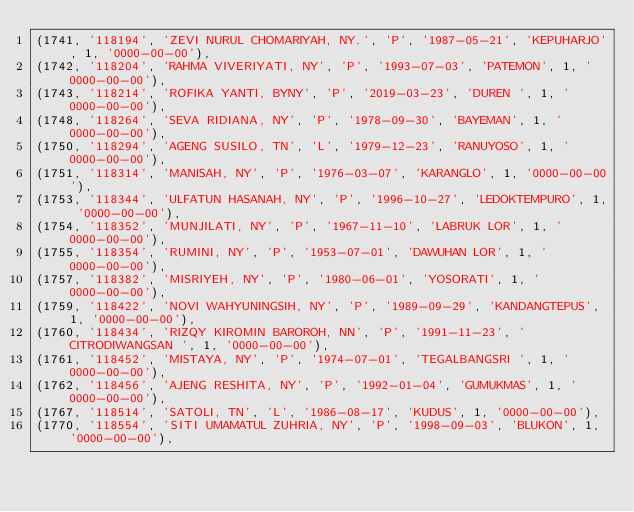Convert code to text. <code><loc_0><loc_0><loc_500><loc_500><_SQL_>(1741, '118194', 'ZEVI NURUL CHOMARIYAH, NY.', 'P', '1987-05-21', 'KEPUHARJO', 1, '0000-00-00'),
(1742, '118204', 'RAHMA VIVERIYATI, NY', 'P', '1993-07-03', 'PATEMON', 1, '0000-00-00'),
(1743, '118214', 'ROFIKA YANTI, BYNY', 'P', '2019-03-23', 'DUREN ', 1, '0000-00-00'),
(1748, '118264', 'SEVA RIDIANA, NY', 'P', '1978-09-30', 'BAYEMAN', 1, '0000-00-00'),
(1750, '118294', 'AGENG SUSILO, TN', 'L', '1979-12-23', 'RANUYOSO', 1, '0000-00-00'),
(1751, '118314', 'MANISAH, NY', 'P', '1976-03-07', 'KARANGLO', 1, '0000-00-00'),
(1753, '118344', 'ULFATUN HASANAH, NY', 'P', '1996-10-27', 'LEDOKTEMPURO', 1, '0000-00-00'),
(1754, '118352', 'MUNJILATI, NY', 'P', '1967-11-10', 'LABRUK LOR', 1, '0000-00-00'),
(1755, '118354', 'RUMINI, NY', 'P', '1953-07-01', 'DAWUHAN LOR', 1, '0000-00-00'),
(1757, '118382', 'MISRIYEH, NY', 'P', '1980-06-01', 'YOSORATI', 1, '0000-00-00'),
(1759, '118422', 'NOVI WAHYUNINGSIH, NY', 'P', '1989-09-29', 'KANDANGTEPUS', 1, '0000-00-00'),
(1760, '118434', 'RIZQY KIROMIN BAROROH, NN', 'P', '1991-11-23', 'CITRODIWANGSAN ', 1, '0000-00-00'),
(1761, '118452', 'MISTAYA, NY', 'P', '1974-07-01', 'TEGALBANGSRI ', 1, '0000-00-00'),
(1762, '118456', 'AJENG RESHITA, NY', 'P', '1992-01-04', 'GUMUKMAS', 1, '0000-00-00'),
(1767, '118514', 'SATOLI, TN', 'L', '1986-08-17', 'KUDUS', 1, '0000-00-00'),
(1770, '118554', 'SITI UMAMATUL ZUHRIA, NY', 'P', '1998-09-03', 'BLUKON', 1, '0000-00-00'),</code> 